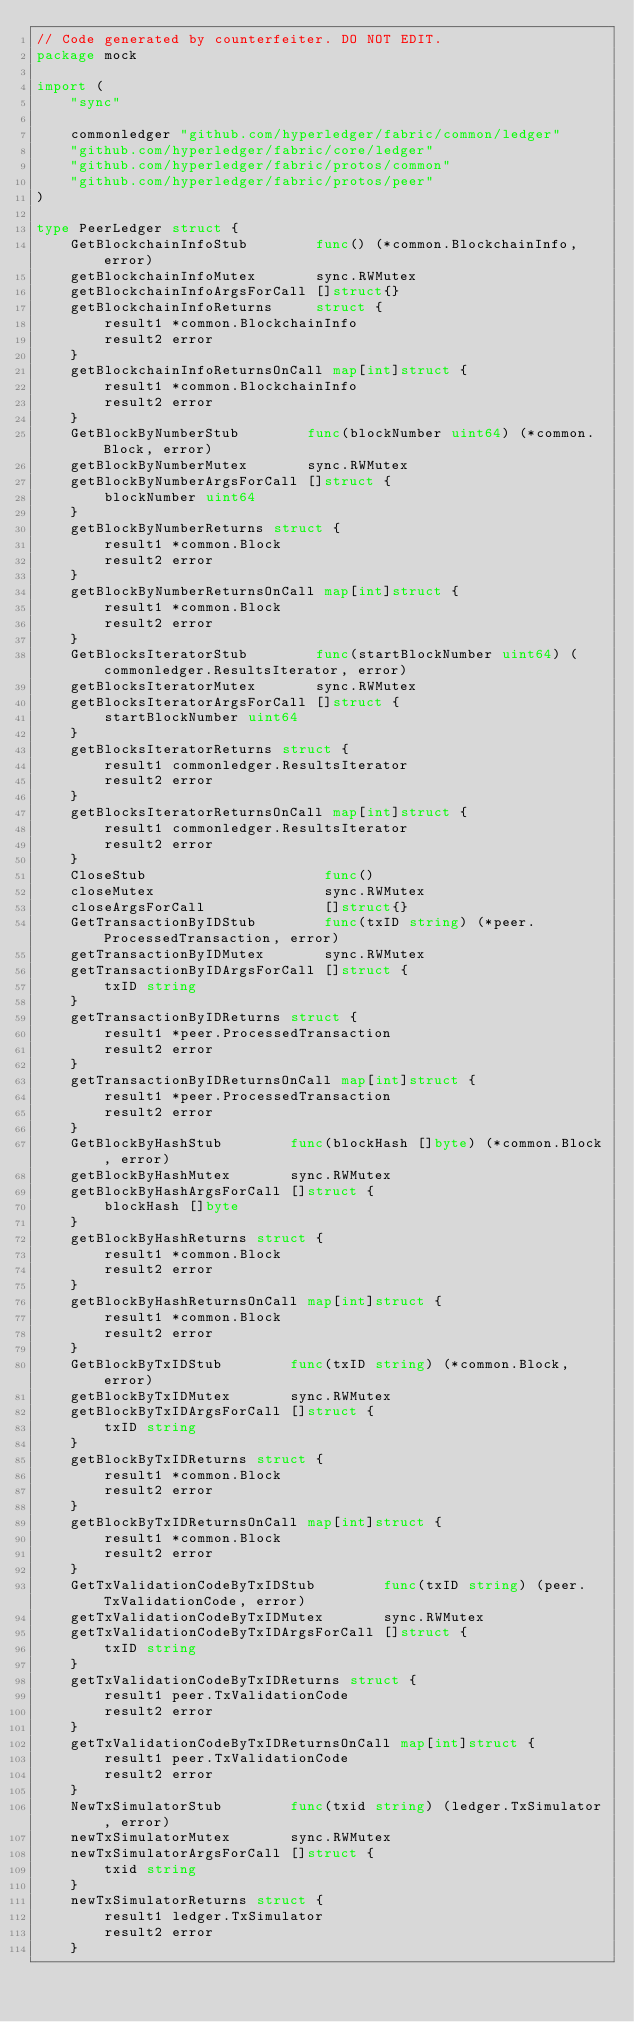<code> <loc_0><loc_0><loc_500><loc_500><_Go_>// Code generated by counterfeiter. DO NOT EDIT.
package mock

import (
	"sync"

	commonledger "github.com/hyperledger/fabric/common/ledger"
	"github.com/hyperledger/fabric/core/ledger"
	"github.com/hyperledger/fabric/protos/common"
	"github.com/hyperledger/fabric/protos/peer"
)

type PeerLedger struct {
	GetBlockchainInfoStub        func() (*common.BlockchainInfo, error)
	getBlockchainInfoMutex       sync.RWMutex
	getBlockchainInfoArgsForCall []struct{}
	getBlockchainInfoReturns     struct {
		result1 *common.BlockchainInfo
		result2 error
	}
	getBlockchainInfoReturnsOnCall map[int]struct {
		result1 *common.BlockchainInfo
		result2 error
	}
	GetBlockByNumberStub        func(blockNumber uint64) (*common.Block, error)
	getBlockByNumberMutex       sync.RWMutex
	getBlockByNumberArgsForCall []struct {
		blockNumber uint64
	}
	getBlockByNumberReturns struct {
		result1 *common.Block
		result2 error
	}
	getBlockByNumberReturnsOnCall map[int]struct {
		result1 *common.Block
		result2 error
	}
	GetBlocksIteratorStub        func(startBlockNumber uint64) (commonledger.ResultsIterator, error)
	getBlocksIteratorMutex       sync.RWMutex
	getBlocksIteratorArgsForCall []struct {
		startBlockNumber uint64
	}
	getBlocksIteratorReturns struct {
		result1 commonledger.ResultsIterator
		result2 error
	}
	getBlocksIteratorReturnsOnCall map[int]struct {
		result1 commonledger.ResultsIterator
		result2 error
	}
	CloseStub                     func()
	closeMutex                    sync.RWMutex
	closeArgsForCall              []struct{}
	GetTransactionByIDStub        func(txID string) (*peer.ProcessedTransaction, error)
	getTransactionByIDMutex       sync.RWMutex
	getTransactionByIDArgsForCall []struct {
		txID string
	}
	getTransactionByIDReturns struct {
		result1 *peer.ProcessedTransaction
		result2 error
	}
	getTransactionByIDReturnsOnCall map[int]struct {
		result1 *peer.ProcessedTransaction
		result2 error
	}
	GetBlockByHashStub        func(blockHash []byte) (*common.Block, error)
	getBlockByHashMutex       sync.RWMutex
	getBlockByHashArgsForCall []struct {
		blockHash []byte
	}
	getBlockByHashReturns struct {
		result1 *common.Block
		result2 error
	}
	getBlockByHashReturnsOnCall map[int]struct {
		result1 *common.Block
		result2 error
	}
	GetBlockByTxIDStub        func(txID string) (*common.Block, error)
	getBlockByTxIDMutex       sync.RWMutex
	getBlockByTxIDArgsForCall []struct {
		txID string
	}
	getBlockByTxIDReturns struct {
		result1 *common.Block
		result2 error
	}
	getBlockByTxIDReturnsOnCall map[int]struct {
		result1 *common.Block
		result2 error
	}
	GetTxValidationCodeByTxIDStub        func(txID string) (peer.TxValidationCode, error)
	getTxValidationCodeByTxIDMutex       sync.RWMutex
	getTxValidationCodeByTxIDArgsForCall []struct {
		txID string
	}
	getTxValidationCodeByTxIDReturns struct {
		result1 peer.TxValidationCode
		result2 error
	}
	getTxValidationCodeByTxIDReturnsOnCall map[int]struct {
		result1 peer.TxValidationCode
		result2 error
	}
	NewTxSimulatorStub        func(txid string) (ledger.TxSimulator, error)
	newTxSimulatorMutex       sync.RWMutex
	newTxSimulatorArgsForCall []struct {
		txid string
	}
	newTxSimulatorReturns struct {
		result1 ledger.TxSimulator
		result2 error
	}</code> 